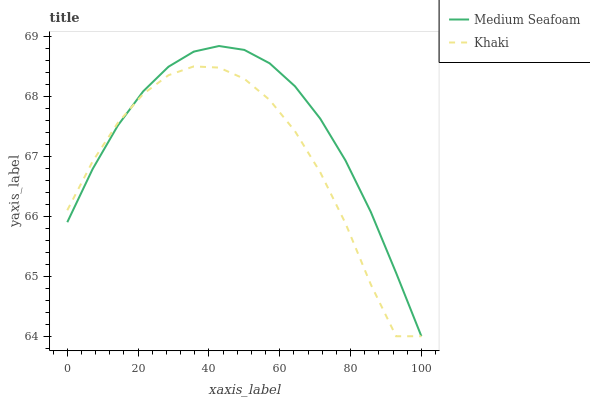Does Medium Seafoam have the minimum area under the curve?
Answer yes or no. No. Is Medium Seafoam the roughest?
Answer yes or no. No. 